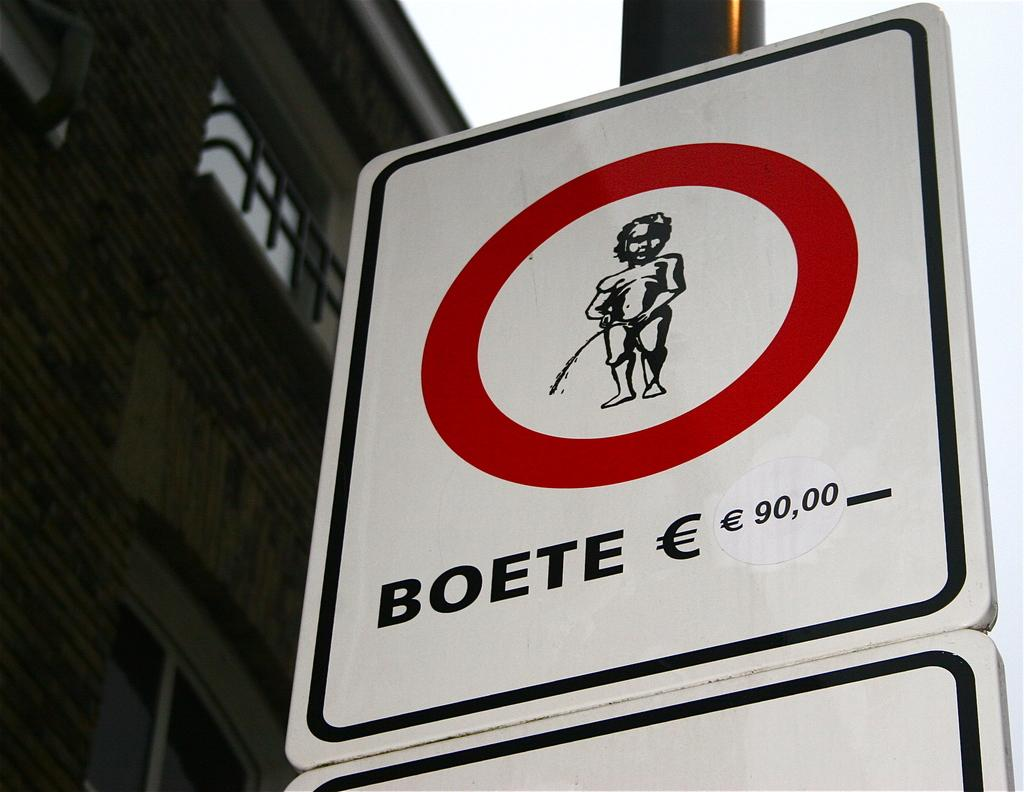Provide a one-sentence caption for the provided image. A sign depicting the fine for Boete being 90,00 euro. 